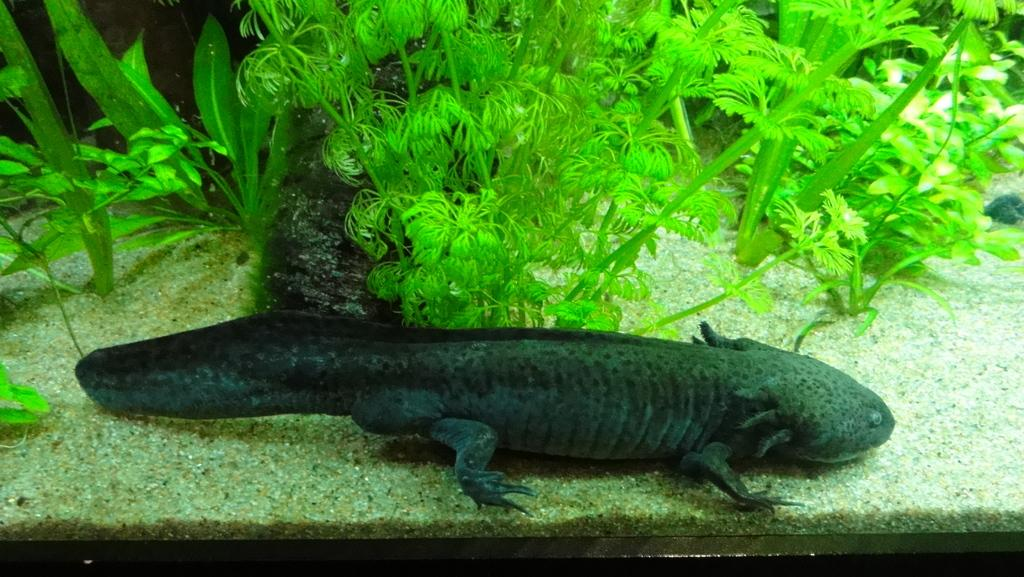What is the main subject on the marble in the image? There is an animal on the marble in the image. What type of vegetation is present in the image? There are plants in the image. Can you describe the color of any object in the image? There is a black color object in the image. In which direction is the animal washing the plants in the image? There is no indication in the image that the animal is washing the plants, nor is there any direction mentioned. 